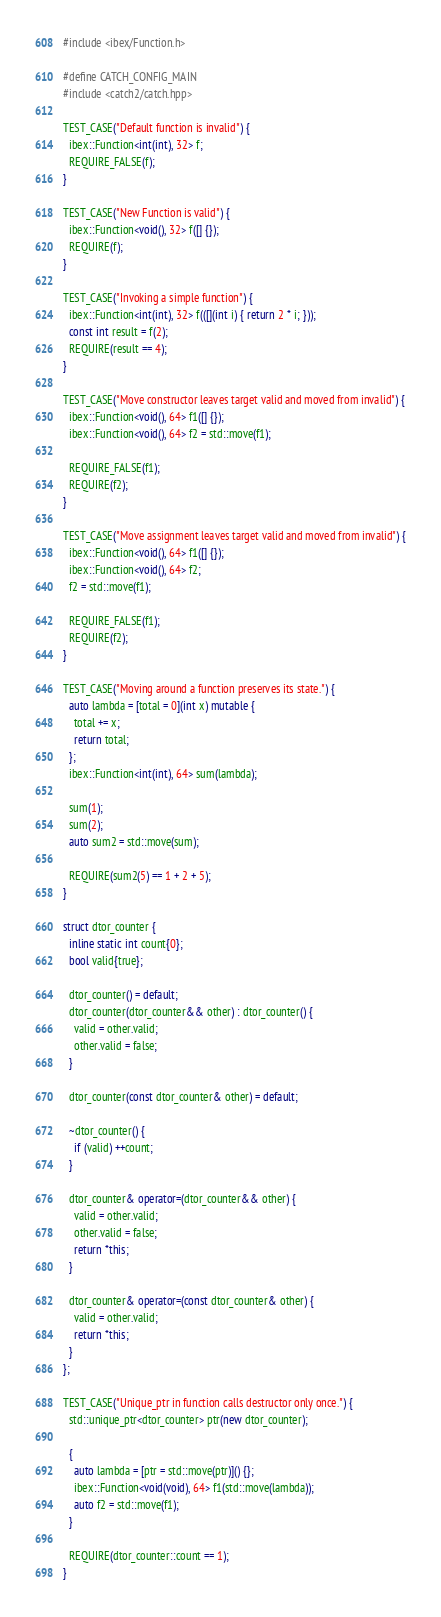<code> <loc_0><loc_0><loc_500><loc_500><_C++_>#include <ibex/Function.h>

#define CATCH_CONFIG_MAIN
#include <catch2/catch.hpp>

TEST_CASE("Default function is invalid") {
  ibex::Function<int(int), 32> f;
  REQUIRE_FALSE(f);
}

TEST_CASE("New Function is valid") {
  ibex::Function<void(), 32> f([] {});
  REQUIRE(f);
}

TEST_CASE("Invoking a simple function") {
  ibex::Function<int(int), 32> f(([](int i) { return 2 * i; }));
  const int result = f(2);
  REQUIRE(result == 4);
}

TEST_CASE("Move constructor leaves target valid and moved from invalid") {
  ibex::Function<void(), 64> f1([] {});
  ibex::Function<void(), 64> f2 = std::move(f1);

  REQUIRE_FALSE(f1);
  REQUIRE(f2);
}

TEST_CASE("Move assignment leaves target valid and moved from invalid") {
  ibex::Function<void(), 64> f1([] {});
  ibex::Function<void(), 64> f2;
  f2 = std::move(f1);

  REQUIRE_FALSE(f1);
  REQUIRE(f2);
}

TEST_CASE("Moving around a function preserves its state.") {
  auto lambda = [total = 0](int x) mutable {
    total += x;
    return total;
  };
  ibex::Function<int(int), 64> sum(lambda);

  sum(1);
  sum(2);
  auto sum2 = std::move(sum);

  REQUIRE(sum2(5) == 1 + 2 + 5);
}

struct dtor_counter {
  inline static int count{0};
  bool valid{true};

  dtor_counter() = default;
  dtor_counter(dtor_counter&& other) : dtor_counter() {
    valid = other.valid;
    other.valid = false;
  }

  dtor_counter(const dtor_counter& other) = default;

  ~dtor_counter() {
    if (valid) ++count;
  }

  dtor_counter& operator=(dtor_counter&& other) {
    valid = other.valid;
    other.valid = false;
    return *this;
  }

  dtor_counter& operator=(const dtor_counter& other) {
    valid = other.valid;
    return *this;
  }
};

TEST_CASE("Unique_ptr in function calls destructor only once.") {
  std::unique_ptr<dtor_counter> ptr(new dtor_counter);

  {
    auto lambda = [ptr = std::move(ptr)]() {};
    ibex::Function<void(void), 64> f1(std::move(lambda));
    auto f2 = std::move(f1);
  }

  REQUIRE(dtor_counter::count == 1);
}
</code> 